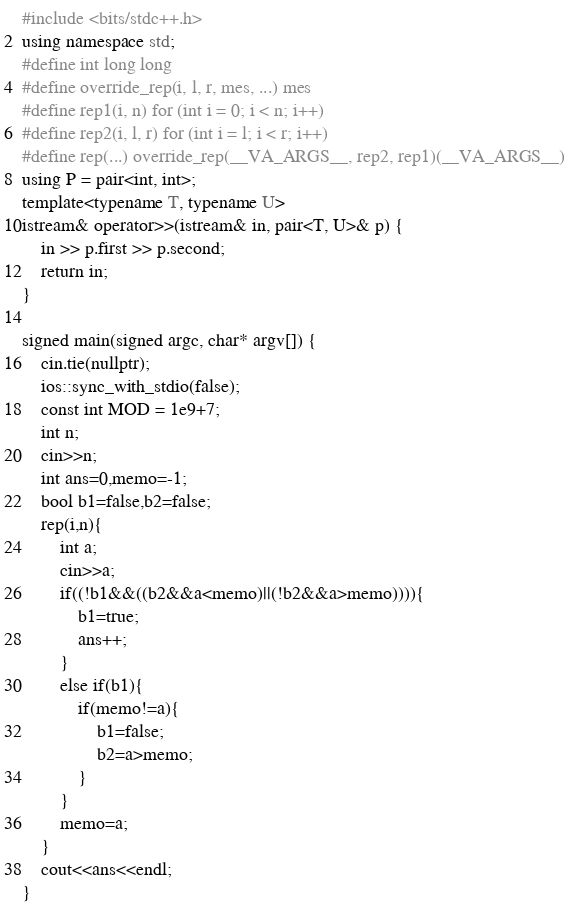Convert code to text. <code><loc_0><loc_0><loc_500><loc_500><_C++_>#include <bits/stdc++.h>
using namespace std;
#define int long long
#define override_rep(i, l, r, mes, ...) mes
#define rep1(i, n) for (int i = 0; i < n; i++)
#define rep2(i, l, r) for (int i = l; i < r; i++)
#define rep(...) override_rep(__VA_ARGS__, rep2, rep1)(__VA_ARGS__)
using P = pair<int, int>;
template<typename T, typename U>
istream& operator>>(istream& in, pair<T, U>& p) {
    in >> p.first >> p.second;
    return in;
}

signed main(signed argc, char* argv[]) {
    cin.tie(nullptr);
    ios::sync_with_stdio(false);
    const int MOD = 1e9+7;
    int n;
    cin>>n;
    int ans=0,memo=-1;
    bool b1=false,b2=false;
    rep(i,n){
        int a;
        cin>>a;
        if((!b1&&((b2&&a<memo)||(!b2&&a>memo)))){
            b1=true;
            ans++;
        }
        else if(b1){
            if(memo!=a){
                b1=false;
                b2=a>memo;
            }
        }
        memo=a;
    }
    cout<<ans<<endl;
}
</code> 